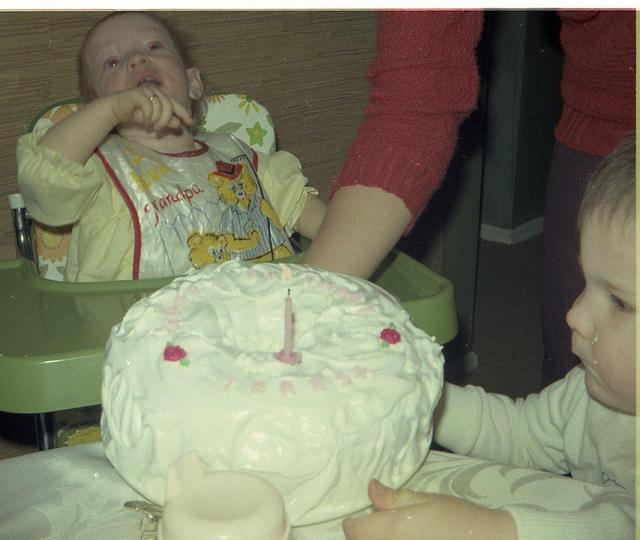Why is there a candle in the cake? birthday 